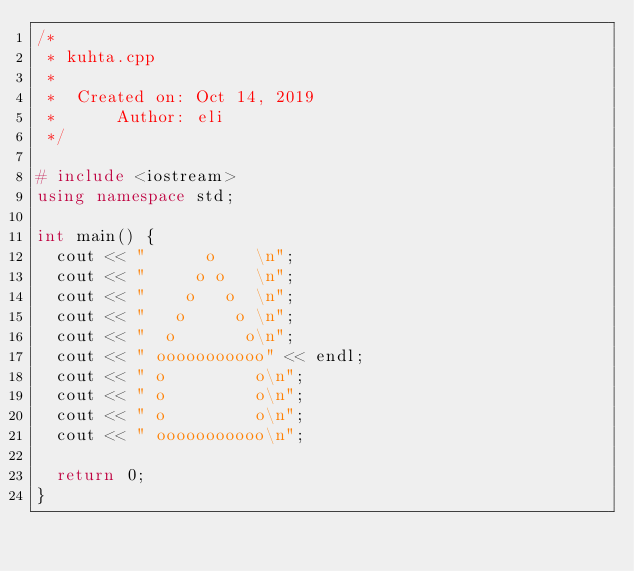Convert code to text. <code><loc_0><loc_0><loc_500><loc_500><_C++_>/*
 * kuhta.cpp
 *
 *  Created on: Oct 14, 2019
 *      Author: eli
 */

# include <iostream>
using namespace std;

int main() {
	cout << "      o    \n";
	cout << "     o o   \n";
	cout << "    o   o  \n";
	cout << "   o     o \n";
	cout << "  o       o\n";
	cout << " ooooooooooo" << endl;
	cout << " o         o\n";
	cout << " o         o\n";
	cout << " o         o\n";
	cout << " ooooooooooo\n";

	return 0;
}

</code> 